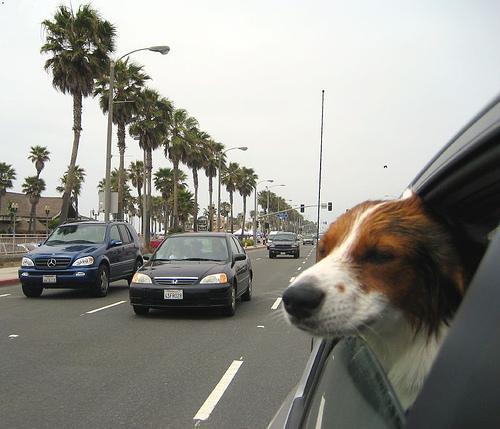How many cars are in the photo?
Give a very brief answer. 3. 